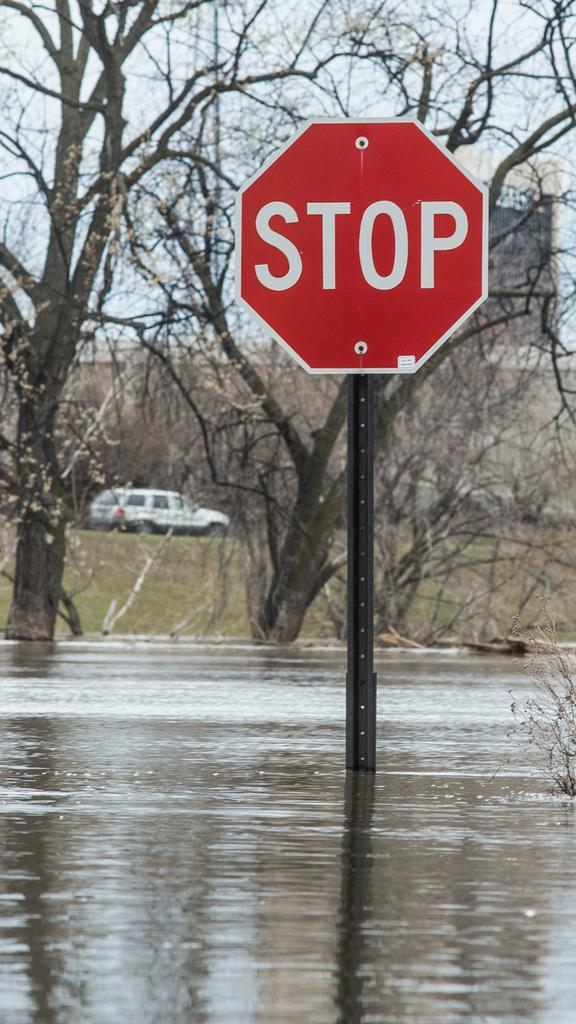Provide a one-sentence caption for the provided image. The stop sign is now in a flooded area with water all around. 